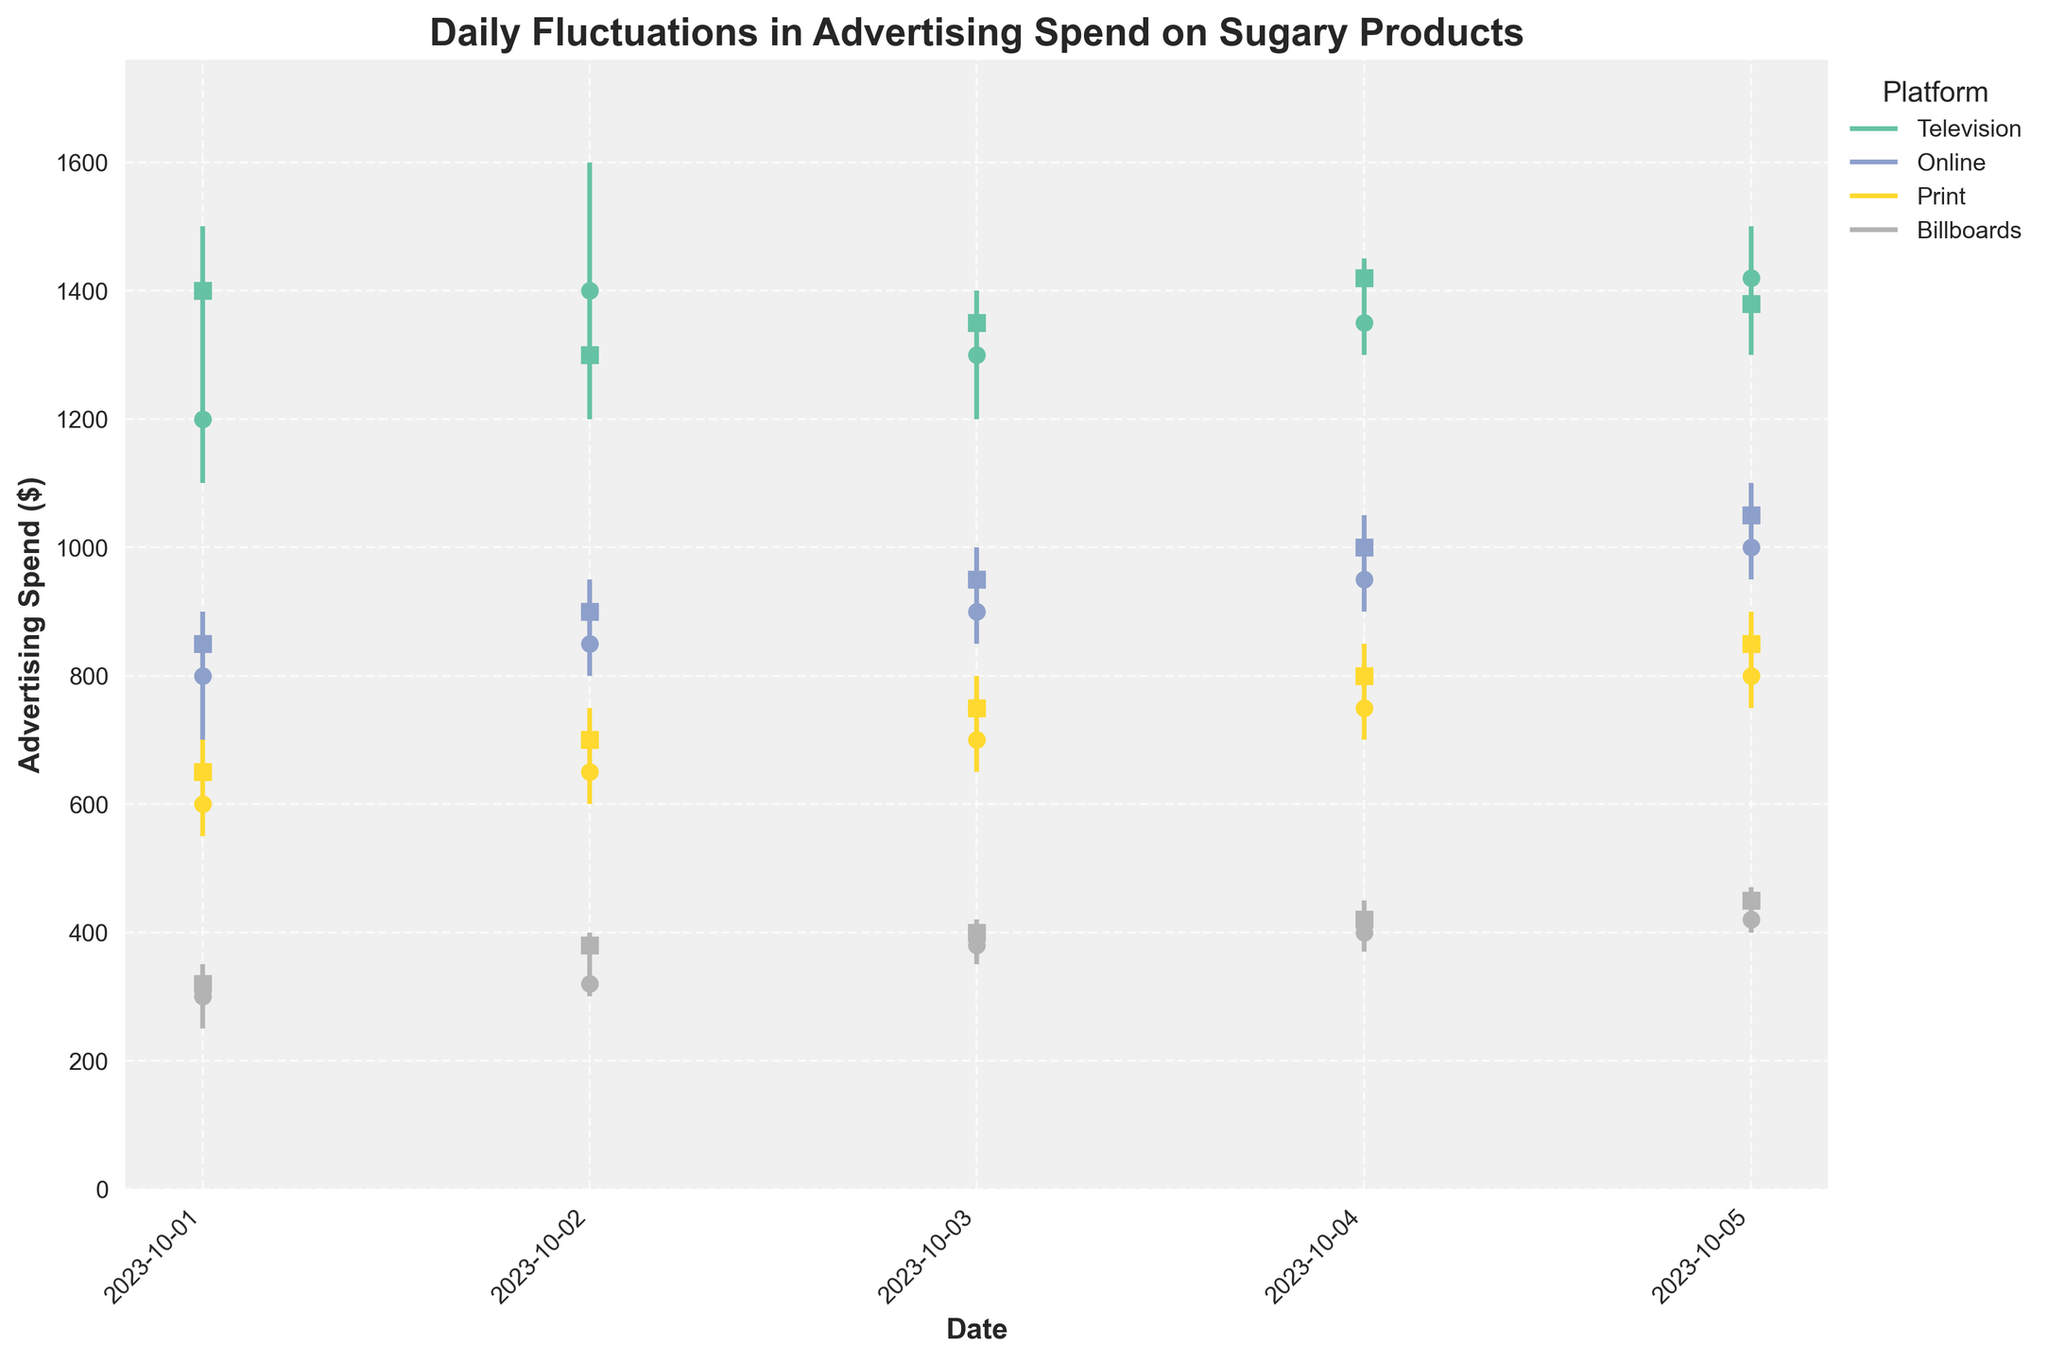What is the highest advertising spend recorded on October 1, 2023, and which platform was it? On the candlestick plot, find the maximum value of the 'High' points for October 1, 2023. It occurs at the 'High' point of the Television platform, which is at 1500.
Answer: 1500, Television On which date does the Online platform have the highest closing spend? Look at the candlestick markers for the Online platform and find the highest closing spend across all dates. The highest value is on October 5, 2023, where the closing spend is 1050.
Answer: October 5, 2023 Compare the opening spend of the Television platform on October 1 and October 5. Which date has a higher value? Identify the 'Open' markers on the candlestick plot for the Television platform on October 1 and October 5. The values are 1200 (October 1) and 1420 (October 5). October 5 has a higher opening value.
Answer: October 5 How did the closing spend of the Print platform change from October 1 to October 3? Find the closing spend of the Print platform on October 1 and October 3. The values are 650 (October 1) and 750 (October 3). The increase is calculated as 750 - 650 = 100.
Answer: Increased by 100 What is the total range (difference between highest and lowest points) of advertising spend for Billboards on October 2, 2023? Look at the candlestick for the Billboards platform on October 2. The highest point (High) is 400, and the lowest point (Low) is 300. The range is calculated as 400 - 300 = 100.
Answer: 100 On which platform did the closing spend increase the most from October 1 to October 5? For each platform, calculate the difference in closing spend between October 1 and October 5. The differences are: Television (1380 - 1400 = -20), Online (1050 - 850 = 200), Print (850 - 650 = 200), Billboards (450 - 320 = 130). The Online and Print platforms both have the highest increase of 200.
Answer: Online and Print Of the platforms studied, which one consistently had the lowest advertising spend throughout the observed period? Look at the candlestick plot across all the dates for the minimum ('Low') values for each platform. Billboards consistently have the lowest values compared to the others.
Answer: Billboards What was the average advertising spend High for the Print platform over the given dates? Sum the 'High' values for the Print platform and divide by the number of dates. The 'High' values are 700, 750, 800, 850, and 900. The sum is 700 + 750 + 800 + 850 + 900 = 4000. There are 5 dates, so the average is 4000 / 5 = 800.
Answer: 800 Which platform had the largest daily fluctuation in spend on October 4, 2023, and what was the fluctuation amount? Calculate the difference between 'High' and 'Low' for each platform on October 4. The fluctuations are: Television (150), Online (150), Print (150), Billboards (80). The highest fluctuation is 150, occurring in Television, Online, and Print.
Answer: Television, Online, and Print, 150 What pattern can be observed from the closing spend of the Television platform over the five days? Observe the closing spend markers for the Television platform over five days: 1400, 1300, 1350, 1420, and 1380. The spend has slight fluctuations but generally trends around the 1400 mark with no significant up or down trend.
Answer: Fluctuates around 1400 